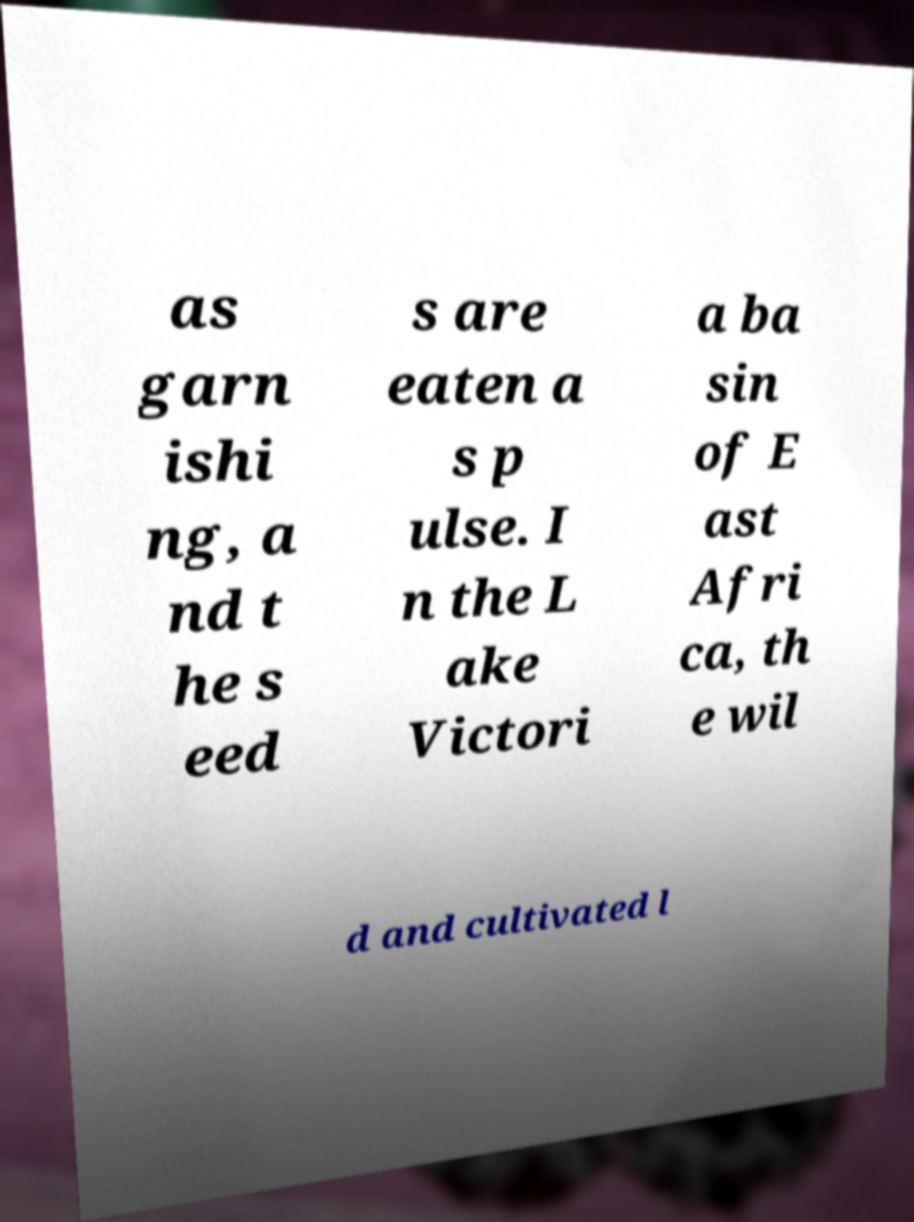Can you read and provide the text displayed in the image?This photo seems to have some interesting text. Can you extract and type it out for me? as garn ishi ng, a nd t he s eed s are eaten a s p ulse. I n the L ake Victori a ba sin of E ast Afri ca, th e wil d and cultivated l 